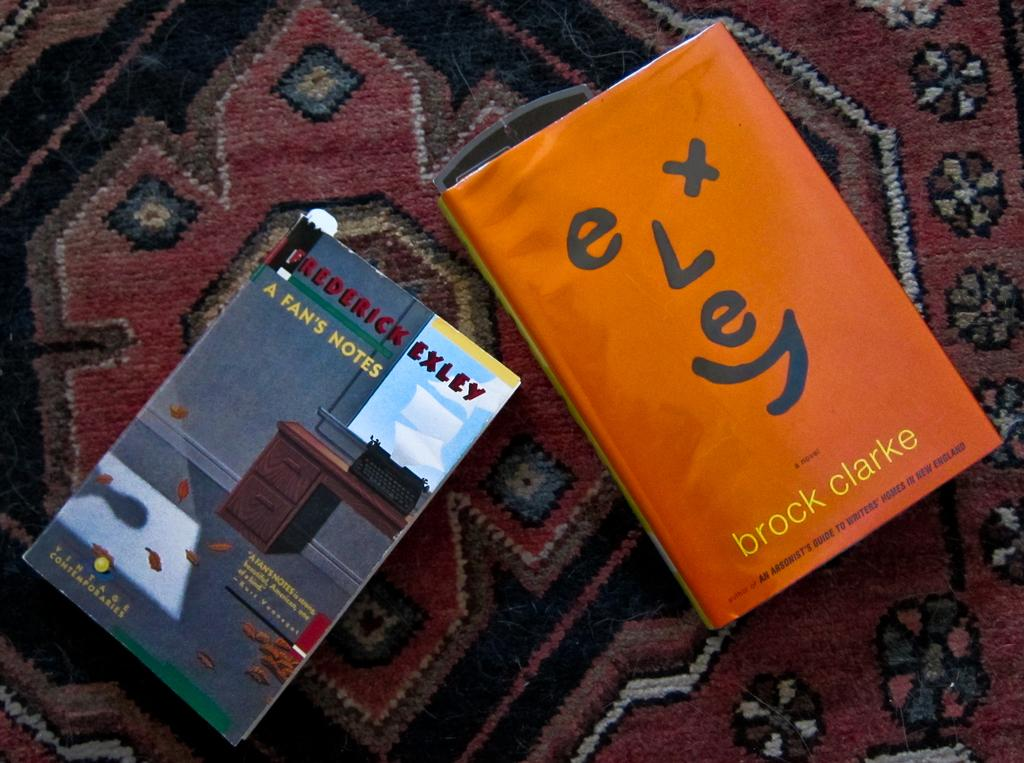<image>
Create a compact narrative representing the image presented. the name Brock is on the orange book 